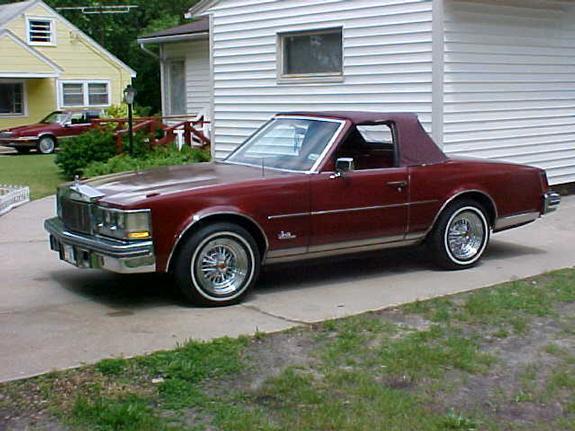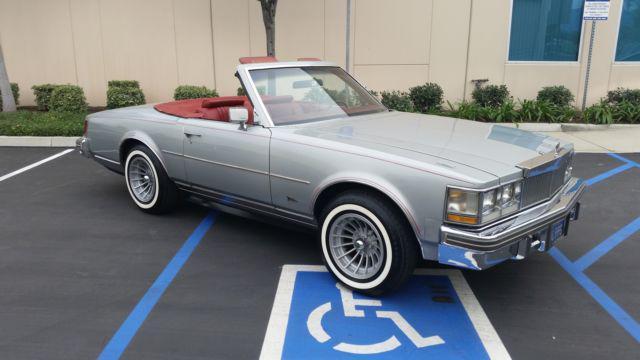The first image is the image on the left, the second image is the image on the right. Assess this claim about the two images: "In one image exactly one convertible car is on the grass.". Correct or not? Answer yes or no. No. The first image is the image on the left, the second image is the image on the right. Evaluate the accuracy of this statement regarding the images: "1 car has it's convertible top up.". Is it true? Answer yes or no. Yes. 